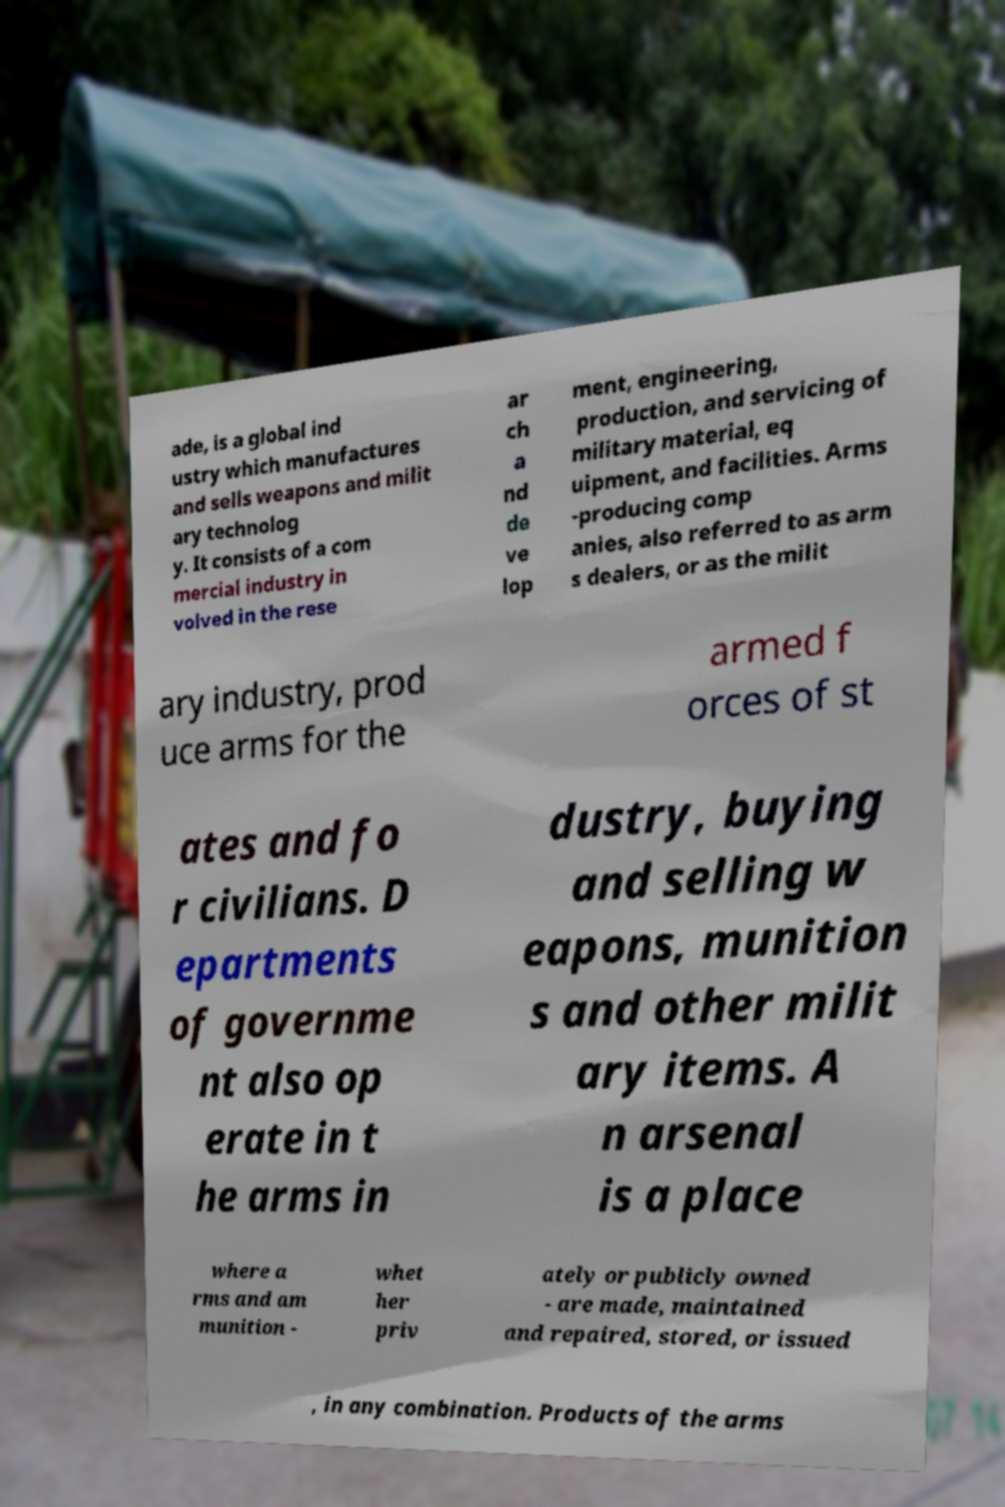Can you read and provide the text displayed in the image?This photo seems to have some interesting text. Can you extract and type it out for me? ade, is a global ind ustry which manufactures and sells weapons and milit ary technolog y. It consists of a com mercial industry in volved in the rese ar ch a nd de ve lop ment, engineering, production, and servicing of military material, eq uipment, and facilities. Arms -producing comp anies, also referred to as arm s dealers, or as the milit ary industry, prod uce arms for the armed f orces of st ates and fo r civilians. D epartments of governme nt also op erate in t he arms in dustry, buying and selling w eapons, munition s and other milit ary items. A n arsenal is a place where a rms and am munition - whet her priv ately or publicly owned - are made, maintained and repaired, stored, or issued , in any combination. Products of the arms 